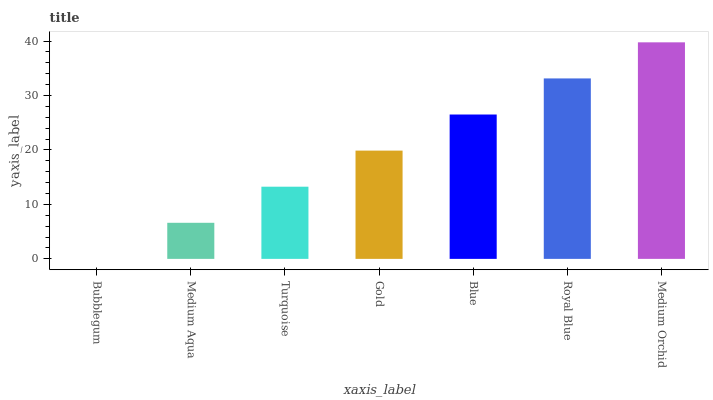Is Medium Orchid the maximum?
Answer yes or no. Yes. Is Medium Aqua the minimum?
Answer yes or no. No. Is Medium Aqua the maximum?
Answer yes or no. No. Is Medium Aqua greater than Bubblegum?
Answer yes or no. Yes. Is Bubblegum less than Medium Aqua?
Answer yes or no. Yes. Is Bubblegum greater than Medium Aqua?
Answer yes or no. No. Is Medium Aqua less than Bubblegum?
Answer yes or no. No. Is Gold the high median?
Answer yes or no. Yes. Is Gold the low median?
Answer yes or no. Yes. Is Bubblegum the high median?
Answer yes or no. No. Is Turquoise the low median?
Answer yes or no. No. 